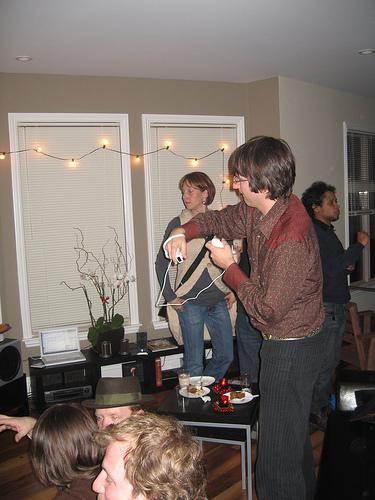Question: what are they doing?
Choices:
A. Having a meeting.
B. Having a party.
C. Watching a game.
D. Teaching a class.
Answer with the letter. Answer: B Question: where are they?
Choices:
A. Bathroom.
B. Bedroom.
C. In the living room.
D. Park.
Answer with the letter. Answer: C Question: what is on the windows?
Choices:
A. Lights.
B. Curtains.
C. Bars.
D. Shades.
Answer with the letter. Answer: A 